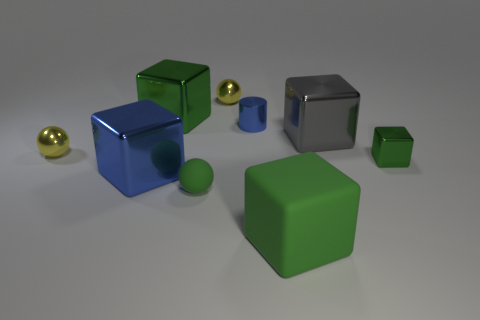How many green cubes must be subtracted to get 1 green cubes? 2 Subtract all green cylinders. How many green cubes are left? 3 Subtract all gray cubes. How many cubes are left? 4 Subtract all blue shiny blocks. How many blocks are left? 4 Subtract all blue blocks. Subtract all gray cylinders. How many blocks are left? 4 Add 1 small blue balls. How many objects exist? 10 Subtract all spheres. How many objects are left? 6 Add 4 green rubber blocks. How many green rubber blocks exist? 5 Subtract 0 purple blocks. How many objects are left? 9 Subtract all tiny yellow shiny spheres. Subtract all gray shiny things. How many objects are left? 6 